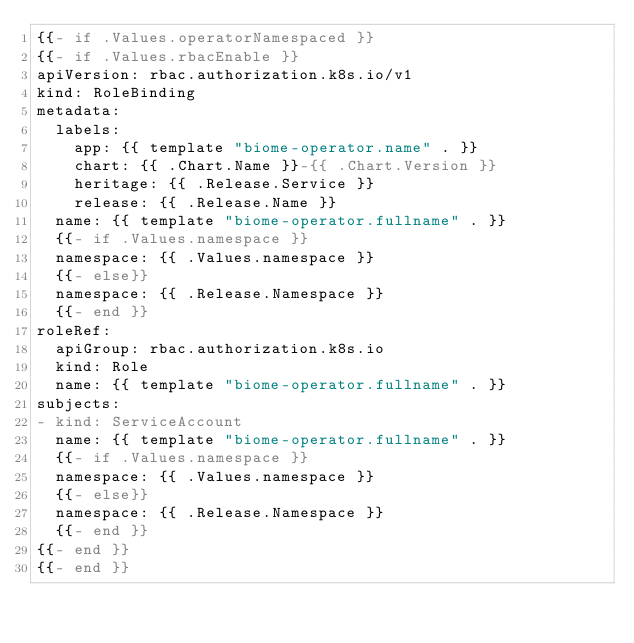Convert code to text. <code><loc_0><loc_0><loc_500><loc_500><_YAML_>{{- if .Values.operatorNamespaced }}
{{- if .Values.rbacEnable }}
apiVersion: rbac.authorization.k8s.io/v1
kind: RoleBinding
metadata:
  labels:
    app: {{ template "biome-operator.name" . }}
    chart: {{ .Chart.Name }}-{{ .Chart.Version }}
    heritage: {{ .Release.Service }}
    release: {{ .Release.Name }}
  name: {{ template "biome-operator.fullname" . }}
  {{- if .Values.namespace }}
  namespace: {{ .Values.namespace }}
  {{- else}}
  namespace: {{ .Release.Namespace }}
  {{- end }}
roleRef:
  apiGroup: rbac.authorization.k8s.io
  kind: Role
  name: {{ template "biome-operator.fullname" . }}
subjects:
- kind: ServiceAccount
  name: {{ template "biome-operator.fullname" . }}
  {{- if .Values.namespace }}
  namespace: {{ .Values.namespace }}
  {{- else}}
  namespace: {{ .Release.Namespace }}
  {{- end }}
{{- end }}
{{- end }}
</code> 